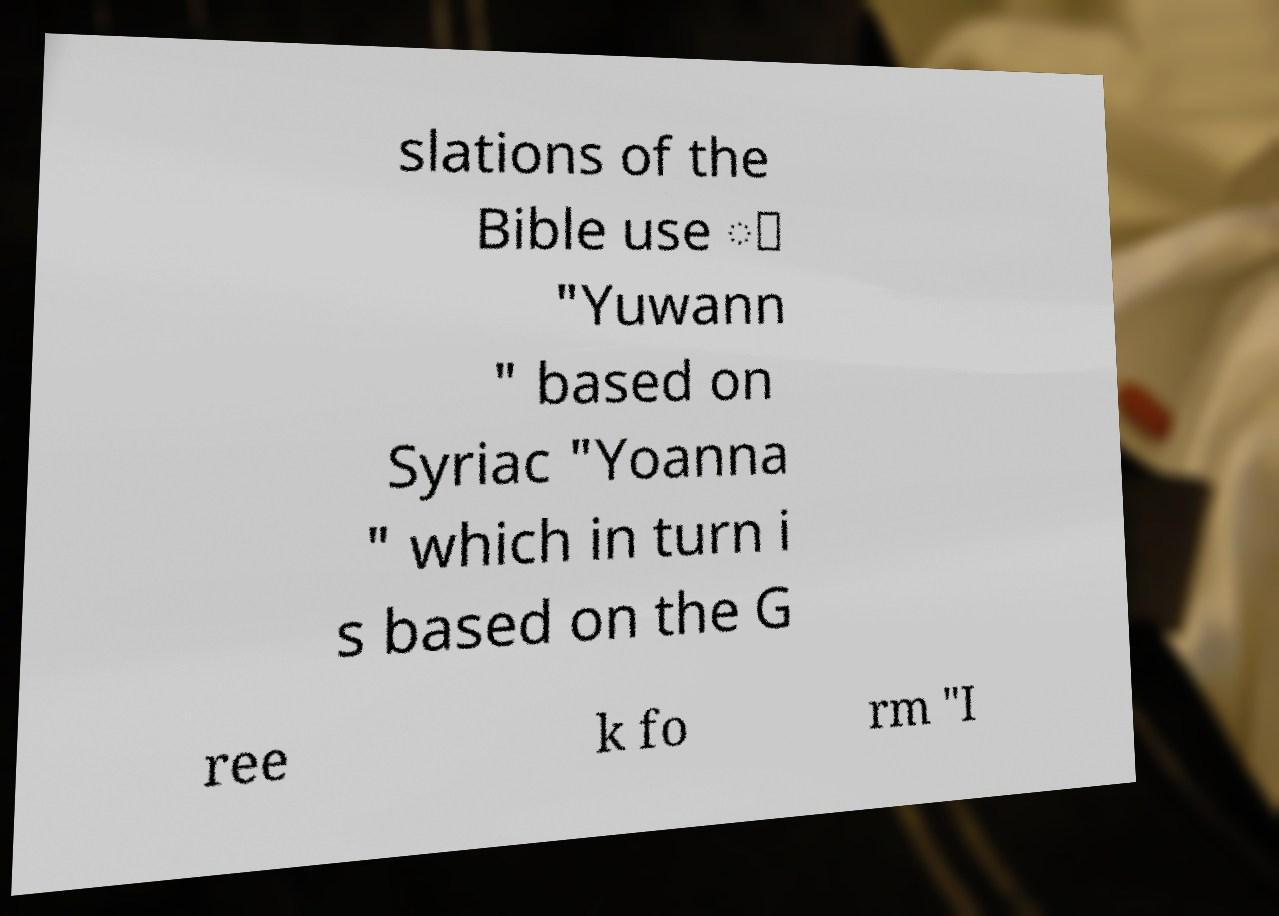Please identify and transcribe the text found in this image. slations of the Bible use ّ "Yuwann " based on Syriac "Yoanna " which in turn i s based on the G ree k fo rm "I 